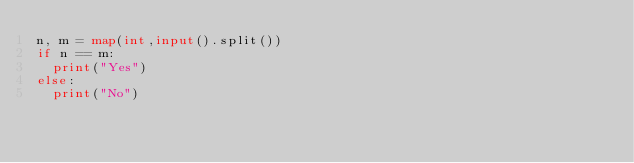<code> <loc_0><loc_0><loc_500><loc_500><_Python_>n, m = map(int,input().split())
if n == m:
  print("Yes")
else:
  print("No")</code> 